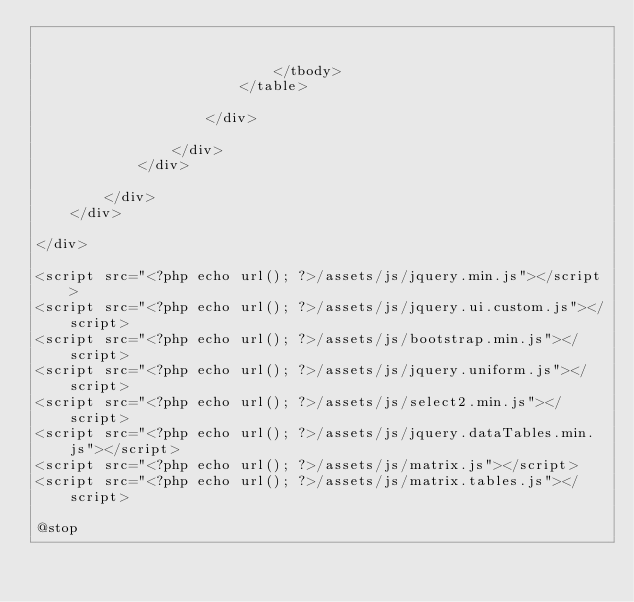Convert code to text. <code><loc_0><loc_0><loc_500><loc_500><_PHP_>

							</tbody>
						</table>

					</div>
					
				</div>
			</div>

		</div>
	</div>

</div>

<script src="<?php echo url(); ?>/assets/js/jquery.min.js"></script> 
<script src="<?php echo url(); ?>/assets/js/jquery.ui.custom.js"></script> 
<script src="<?php echo url(); ?>/assets/js/bootstrap.min.js"></script> 
<script src="<?php echo url(); ?>/assets/js/jquery.uniform.js"></script> 
<script src="<?php echo url(); ?>/assets/js/select2.min.js"></script> 
<script src="<?php echo url(); ?>/assets/js/jquery.dataTables.min.js"></script> 
<script src="<?php echo url(); ?>/assets/js/matrix.js"></script> 
<script src="<?php echo url(); ?>/assets/js/matrix.tables.js"></script>

@stop

</code> 